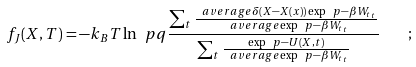Convert formula to latex. <formula><loc_0><loc_0><loc_500><loc_500>f _ { J } ( X , T ) = - k _ { B } T \ln \ p q { \frac { \sum _ { t } \frac { \ a v e r a g e { \delta ( X - X ( x ) ) \exp \ p { - \beta W _ { t } } } _ { t } } { \ a v e r a g e { \exp \ p { - \beta W _ { t } } } _ { t } } } { \sum _ { t } \frac { \exp \ p { - U ( X , t ) } } { \ a v e r a g e { \exp \ p { - \beta W _ { t } } } _ { t } } } } \quad ;</formula> 